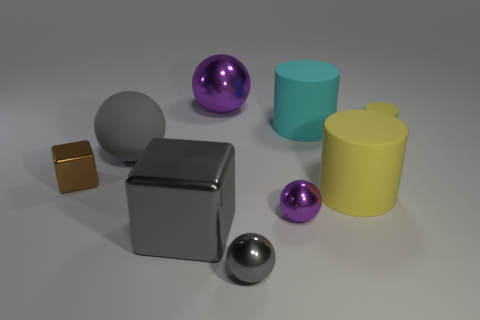There is a gray ball behind the metal block right of the large sphere in front of the tiny matte object; what is its material?
Your answer should be very brief. Rubber. Does the big matte cylinder that is on the right side of the big cyan rubber thing have the same color as the tiny rubber object?
Offer a very short reply. Yes. How many brown things are either tiny objects or cylinders?
Provide a succinct answer. 1. What number of other objects are the same shape as the cyan matte object?
Your response must be concise. 2. Are the large gray cube and the large yellow thing made of the same material?
Your response must be concise. No. There is a large object that is both in front of the large gray sphere and to the right of the tiny gray metallic sphere; what is it made of?
Provide a succinct answer. Rubber. The tiny metallic object that is to the right of the tiny gray ball is what color?
Offer a terse response. Purple. Is the number of purple metallic spheres behind the gray matte ball greater than the number of small cyan cubes?
Provide a short and direct response. Yes. How many other objects are the same size as the gray rubber object?
Offer a very short reply. 4. There is a big gray shiny cube; what number of large gray objects are behind it?
Your answer should be compact. 1. 